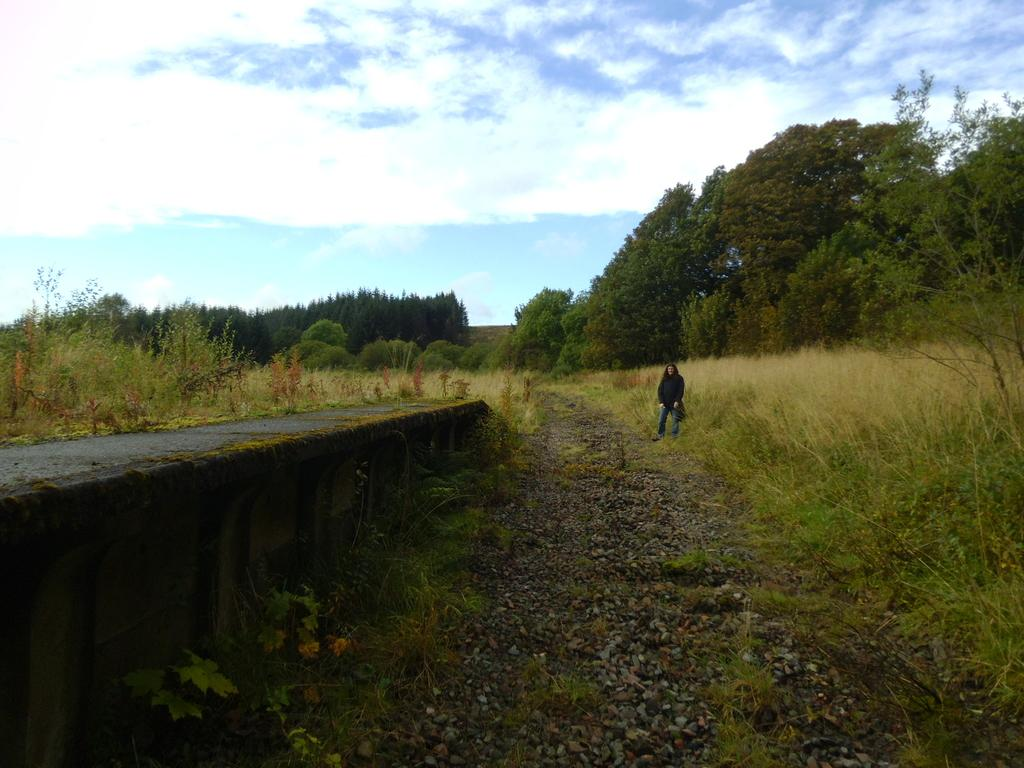What is the main subject of the image? There is a person standing in the image. What is the person standing on? The person is standing on land covered with plants. What type of vegetation can be seen in the image? Trees are present in the image. What is visible in the background of the image? The sky is visible in the image, and clouds are present in the sky. What type of competition is the person participating in within the image? There is no competition present in the image; it simply shows a person standing on land covered with plants. 